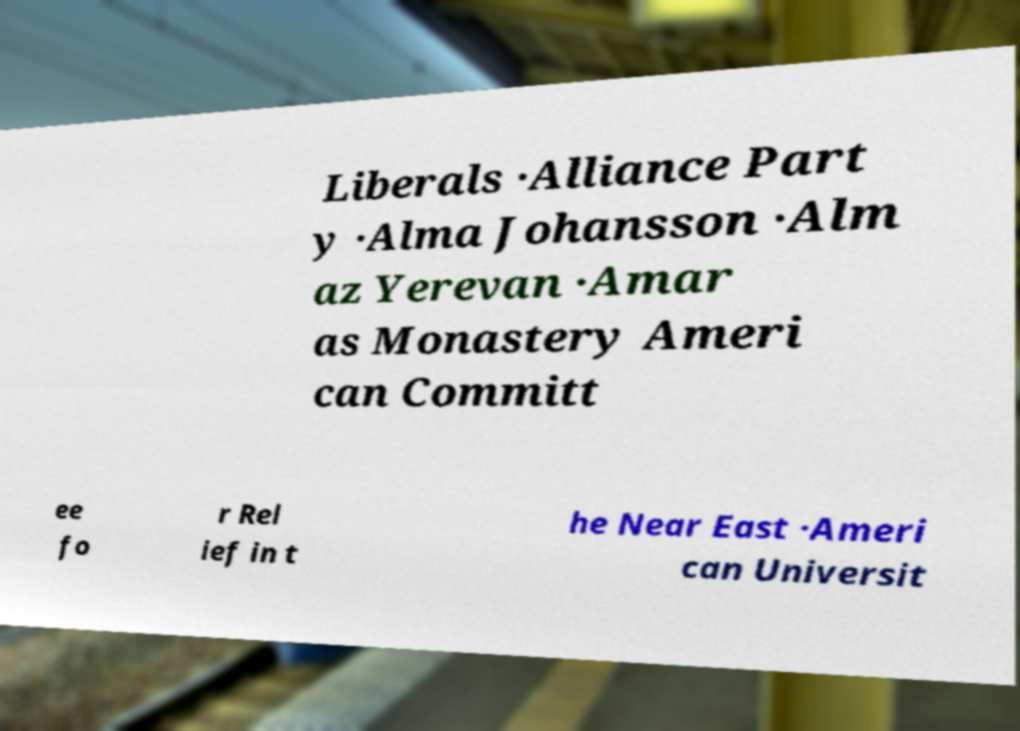There's text embedded in this image that I need extracted. Can you transcribe it verbatim? Liberals ·Alliance Part y ·Alma Johansson ·Alm az Yerevan ·Amar as Monastery Ameri can Committ ee fo r Rel ief in t he Near East ·Ameri can Universit 